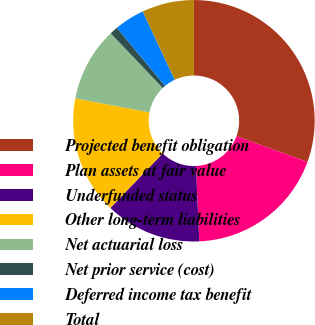<chart> <loc_0><loc_0><loc_500><loc_500><pie_chart><fcel>Projected benefit obligation<fcel>Plan assets at fair value<fcel>Underfunded status<fcel>Other long-term liabilities<fcel>Net actuarial loss<fcel>Net prior service (cost)<fcel>Deferred income tax benefit<fcel>Total<nl><fcel>30.53%<fcel>18.76%<fcel>12.87%<fcel>15.81%<fcel>9.92%<fcel>1.09%<fcel>4.04%<fcel>6.98%<nl></chart> 